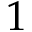<formula> <loc_0><loc_0><loc_500><loc_500>1</formula> 